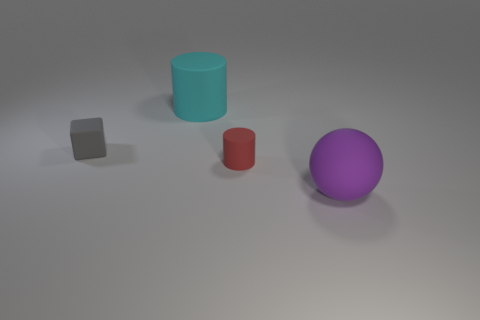Is the number of tiny matte things that are to the right of the sphere less than the number of small matte cubes that are right of the large cyan matte cylinder?
Provide a succinct answer. No. What number of big metallic balls are there?
Offer a very short reply. 0. What is the color of the rubber object that is right of the small cylinder?
Provide a short and direct response. Purple. What is the size of the gray rubber object?
Ensure brevity in your answer.  Small. There is a cube; is its color the same as the large rubber object that is behind the large purple matte object?
Provide a succinct answer. No. What color is the cylinder to the left of the small rubber object that is to the right of the gray rubber thing?
Provide a short and direct response. Cyan. Is there any other thing that has the same size as the cyan matte thing?
Your response must be concise. Yes. Do the rubber thing that is left of the cyan cylinder and the red object have the same shape?
Offer a terse response. No. What number of matte things are both to the right of the big cyan thing and to the left of the purple matte sphere?
Your response must be concise. 1. There is a tiny rubber object to the left of the matte cylinder that is in front of the matte thing that is behind the small gray object; what is its color?
Your answer should be very brief. Gray. 